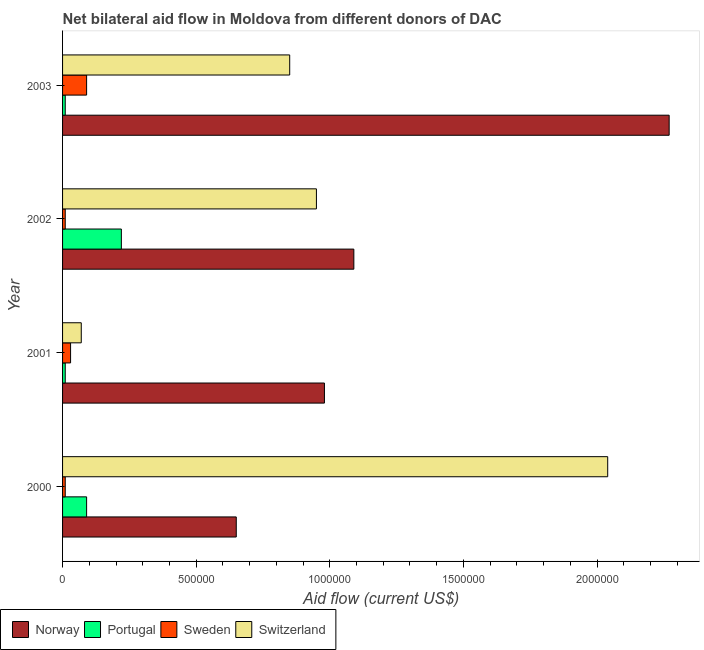How many different coloured bars are there?
Give a very brief answer. 4. How many groups of bars are there?
Offer a terse response. 4. Are the number of bars per tick equal to the number of legend labels?
Keep it short and to the point. Yes. Are the number of bars on each tick of the Y-axis equal?
Your answer should be very brief. Yes. How many bars are there on the 1st tick from the bottom?
Offer a very short reply. 4. What is the label of the 3rd group of bars from the top?
Give a very brief answer. 2001. In how many cases, is the number of bars for a given year not equal to the number of legend labels?
Your answer should be very brief. 0. What is the amount of aid given by switzerland in 2001?
Keep it short and to the point. 7.00e+04. Across all years, what is the maximum amount of aid given by switzerland?
Your response must be concise. 2.04e+06. Across all years, what is the minimum amount of aid given by switzerland?
Make the answer very short. 7.00e+04. In which year was the amount of aid given by norway minimum?
Provide a succinct answer. 2000. What is the total amount of aid given by norway in the graph?
Offer a terse response. 4.99e+06. What is the difference between the amount of aid given by norway in 2000 and the amount of aid given by portugal in 2002?
Your answer should be very brief. 4.30e+05. What is the average amount of aid given by sweden per year?
Provide a short and direct response. 3.50e+04. In the year 2000, what is the difference between the amount of aid given by switzerland and amount of aid given by sweden?
Provide a succinct answer. 2.03e+06. Is the amount of aid given by portugal in 2000 less than that in 2001?
Offer a very short reply. No. What is the difference between the highest and the second highest amount of aid given by norway?
Make the answer very short. 1.18e+06. What is the difference between the highest and the lowest amount of aid given by sweden?
Provide a succinct answer. 8.00e+04. In how many years, is the amount of aid given by portugal greater than the average amount of aid given by portugal taken over all years?
Make the answer very short. 2. Is the sum of the amount of aid given by sweden in 2000 and 2001 greater than the maximum amount of aid given by portugal across all years?
Ensure brevity in your answer.  No. What does the 1st bar from the top in 2002 represents?
Keep it short and to the point. Switzerland. Is it the case that in every year, the sum of the amount of aid given by norway and amount of aid given by portugal is greater than the amount of aid given by sweden?
Keep it short and to the point. Yes. How many bars are there?
Give a very brief answer. 16. Are all the bars in the graph horizontal?
Give a very brief answer. Yes. What is the difference between two consecutive major ticks on the X-axis?
Keep it short and to the point. 5.00e+05. Does the graph contain grids?
Give a very brief answer. No. How are the legend labels stacked?
Make the answer very short. Horizontal. What is the title of the graph?
Offer a terse response. Net bilateral aid flow in Moldova from different donors of DAC. What is the label or title of the X-axis?
Your answer should be very brief. Aid flow (current US$). What is the Aid flow (current US$) in Norway in 2000?
Your answer should be compact. 6.50e+05. What is the Aid flow (current US$) in Sweden in 2000?
Your response must be concise. 10000. What is the Aid flow (current US$) of Switzerland in 2000?
Your answer should be very brief. 2.04e+06. What is the Aid flow (current US$) in Norway in 2001?
Your answer should be compact. 9.80e+05. What is the Aid flow (current US$) of Portugal in 2001?
Make the answer very short. 10000. What is the Aid flow (current US$) of Norway in 2002?
Provide a succinct answer. 1.09e+06. What is the Aid flow (current US$) of Portugal in 2002?
Give a very brief answer. 2.20e+05. What is the Aid flow (current US$) in Switzerland in 2002?
Provide a short and direct response. 9.50e+05. What is the Aid flow (current US$) of Norway in 2003?
Provide a short and direct response. 2.27e+06. What is the Aid flow (current US$) of Switzerland in 2003?
Offer a terse response. 8.50e+05. Across all years, what is the maximum Aid flow (current US$) in Norway?
Ensure brevity in your answer.  2.27e+06. Across all years, what is the maximum Aid flow (current US$) in Portugal?
Provide a short and direct response. 2.20e+05. Across all years, what is the maximum Aid flow (current US$) in Sweden?
Provide a succinct answer. 9.00e+04. Across all years, what is the maximum Aid flow (current US$) in Switzerland?
Make the answer very short. 2.04e+06. Across all years, what is the minimum Aid flow (current US$) in Norway?
Provide a short and direct response. 6.50e+05. Across all years, what is the minimum Aid flow (current US$) of Sweden?
Provide a short and direct response. 10000. Across all years, what is the minimum Aid flow (current US$) of Switzerland?
Your response must be concise. 7.00e+04. What is the total Aid flow (current US$) in Norway in the graph?
Make the answer very short. 4.99e+06. What is the total Aid flow (current US$) in Portugal in the graph?
Give a very brief answer. 3.30e+05. What is the total Aid flow (current US$) of Sweden in the graph?
Provide a short and direct response. 1.40e+05. What is the total Aid flow (current US$) in Switzerland in the graph?
Provide a short and direct response. 3.91e+06. What is the difference between the Aid flow (current US$) in Norway in 2000 and that in 2001?
Your answer should be compact. -3.30e+05. What is the difference between the Aid flow (current US$) in Sweden in 2000 and that in 2001?
Provide a short and direct response. -2.00e+04. What is the difference between the Aid flow (current US$) in Switzerland in 2000 and that in 2001?
Provide a succinct answer. 1.97e+06. What is the difference between the Aid flow (current US$) in Norway in 2000 and that in 2002?
Your response must be concise. -4.40e+05. What is the difference between the Aid flow (current US$) of Portugal in 2000 and that in 2002?
Offer a terse response. -1.30e+05. What is the difference between the Aid flow (current US$) of Sweden in 2000 and that in 2002?
Provide a short and direct response. 0. What is the difference between the Aid flow (current US$) of Switzerland in 2000 and that in 2002?
Your answer should be compact. 1.09e+06. What is the difference between the Aid flow (current US$) of Norway in 2000 and that in 2003?
Keep it short and to the point. -1.62e+06. What is the difference between the Aid flow (current US$) of Portugal in 2000 and that in 2003?
Offer a terse response. 8.00e+04. What is the difference between the Aid flow (current US$) in Switzerland in 2000 and that in 2003?
Your answer should be very brief. 1.19e+06. What is the difference between the Aid flow (current US$) in Portugal in 2001 and that in 2002?
Provide a short and direct response. -2.10e+05. What is the difference between the Aid flow (current US$) in Sweden in 2001 and that in 2002?
Your answer should be very brief. 2.00e+04. What is the difference between the Aid flow (current US$) in Switzerland in 2001 and that in 2002?
Your response must be concise. -8.80e+05. What is the difference between the Aid flow (current US$) in Norway in 2001 and that in 2003?
Make the answer very short. -1.29e+06. What is the difference between the Aid flow (current US$) of Switzerland in 2001 and that in 2003?
Offer a very short reply. -7.80e+05. What is the difference between the Aid flow (current US$) in Norway in 2002 and that in 2003?
Keep it short and to the point. -1.18e+06. What is the difference between the Aid flow (current US$) of Switzerland in 2002 and that in 2003?
Your answer should be very brief. 1.00e+05. What is the difference between the Aid flow (current US$) of Norway in 2000 and the Aid flow (current US$) of Portugal in 2001?
Offer a very short reply. 6.40e+05. What is the difference between the Aid flow (current US$) in Norway in 2000 and the Aid flow (current US$) in Sweden in 2001?
Offer a very short reply. 6.20e+05. What is the difference between the Aid flow (current US$) in Norway in 2000 and the Aid flow (current US$) in Switzerland in 2001?
Your answer should be compact. 5.80e+05. What is the difference between the Aid flow (current US$) of Portugal in 2000 and the Aid flow (current US$) of Sweden in 2001?
Offer a very short reply. 6.00e+04. What is the difference between the Aid flow (current US$) in Norway in 2000 and the Aid flow (current US$) in Sweden in 2002?
Provide a short and direct response. 6.40e+05. What is the difference between the Aid flow (current US$) in Portugal in 2000 and the Aid flow (current US$) in Sweden in 2002?
Your answer should be very brief. 8.00e+04. What is the difference between the Aid flow (current US$) of Portugal in 2000 and the Aid flow (current US$) of Switzerland in 2002?
Keep it short and to the point. -8.60e+05. What is the difference between the Aid flow (current US$) of Sweden in 2000 and the Aid flow (current US$) of Switzerland in 2002?
Offer a terse response. -9.40e+05. What is the difference between the Aid flow (current US$) of Norway in 2000 and the Aid flow (current US$) of Portugal in 2003?
Your answer should be very brief. 6.40e+05. What is the difference between the Aid flow (current US$) of Norway in 2000 and the Aid flow (current US$) of Sweden in 2003?
Provide a short and direct response. 5.60e+05. What is the difference between the Aid flow (current US$) of Portugal in 2000 and the Aid flow (current US$) of Switzerland in 2003?
Ensure brevity in your answer.  -7.60e+05. What is the difference between the Aid flow (current US$) in Sweden in 2000 and the Aid flow (current US$) in Switzerland in 2003?
Your answer should be very brief. -8.40e+05. What is the difference between the Aid flow (current US$) in Norway in 2001 and the Aid flow (current US$) in Portugal in 2002?
Give a very brief answer. 7.60e+05. What is the difference between the Aid flow (current US$) of Norway in 2001 and the Aid flow (current US$) of Sweden in 2002?
Your response must be concise. 9.70e+05. What is the difference between the Aid flow (current US$) in Portugal in 2001 and the Aid flow (current US$) in Switzerland in 2002?
Provide a succinct answer. -9.40e+05. What is the difference between the Aid flow (current US$) in Sweden in 2001 and the Aid flow (current US$) in Switzerland in 2002?
Your answer should be very brief. -9.20e+05. What is the difference between the Aid flow (current US$) in Norway in 2001 and the Aid flow (current US$) in Portugal in 2003?
Give a very brief answer. 9.70e+05. What is the difference between the Aid flow (current US$) of Norway in 2001 and the Aid flow (current US$) of Sweden in 2003?
Give a very brief answer. 8.90e+05. What is the difference between the Aid flow (current US$) in Norway in 2001 and the Aid flow (current US$) in Switzerland in 2003?
Make the answer very short. 1.30e+05. What is the difference between the Aid flow (current US$) of Portugal in 2001 and the Aid flow (current US$) of Switzerland in 2003?
Your answer should be very brief. -8.40e+05. What is the difference between the Aid flow (current US$) in Sweden in 2001 and the Aid flow (current US$) in Switzerland in 2003?
Give a very brief answer. -8.20e+05. What is the difference between the Aid flow (current US$) of Norway in 2002 and the Aid flow (current US$) of Portugal in 2003?
Your answer should be compact. 1.08e+06. What is the difference between the Aid flow (current US$) in Norway in 2002 and the Aid flow (current US$) in Sweden in 2003?
Your answer should be compact. 1.00e+06. What is the difference between the Aid flow (current US$) of Portugal in 2002 and the Aid flow (current US$) of Switzerland in 2003?
Offer a very short reply. -6.30e+05. What is the difference between the Aid flow (current US$) in Sweden in 2002 and the Aid flow (current US$) in Switzerland in 2003?
Give a very brief answer. -8.40e+05. What is the average Aid flow (current US$) of Norway per year?
Give a very brief answer. 1.25e+06. What is the average Aid flow (current US$) of Portugal per year?
Offer a terse response. 8.25e+04. What is the average Aid flow (current US$) in Sweden per year?
Offer a terse response. 3.50e+04. What is the average Aid flow (current US$) of Switzerland per year?
Keep it short and to the point. 9.78e+05. In the year 2000, what is the difference between the Aid flow (current US$) of Norway and Aid flow (current US$) of Portugal?
Your answer should be compact. 5.60e+05. In the year 2000, what is the difference between the Aid flow (current US$) in Norway and Aid flow (current US$) in Sweden?
Your answer should be compact. 6.40e+05. In the year 2000, what is the difference between the Aid flow (current US$) in Norway and Aid flow (current US$) in Switzerland?
Your answer should be very brief. -1.39e+06. In the year 2000, what is the difference between the Aid flow (current US$) in Portugal and Aid flow (current US$) in Sweden?
Ensure brevity in your answer.  8.00e+04. In the year 2000, what is the difference between the Aid flow (current US$) of Portugal and Aid flow (current US$) of Switzerland?
Your answer should be compact. -1.95e+06. In the year 2000, what is the difference between the Aid flow (current US$) in Sweden and Aid flow (current US$) in Switzerland?
Provide a succinct answer. -2.03e+06. In the year 2001, what is the difference between the Aid flow (current US$) in Norway and Aid flow (current US$) in Portugal?
Ensure brevity in your answer.  9.70e+05. In the year 2001, what is the difference between the Aid flow (current US$) of Norway and Aid flow (current US$) of Sweden?
Offer a terse response. 9.50e+05. In the year 2001, what is the difference between the Aid flow (current US$) in Norway and Aid flow (current US$) in Switzerland?
Make the answer very short. 9.10e+05. In the year 2001, what is the difference between the Aid flow (current US$) in Portugal and Aid flow (current US$) in Switzerland?
Offer a very short reply. -6.00e+04. In the year 2002, what is the difference between the Aid flow (current US$) of Norway and Aid flow (current US$) of Portugal?
Ensure brevity in your answer.  8.70e+05. In the year 2002, what is the difference between the Aid flow (current US$) of Norway and Aid flow (current US$) of Sweden?
Provide a short and direct response. 1.08e+06. In the year 2002, what is the difference between the Aid flow (current US$) in Norway and Aid flow (current US$) in Switzerland?
Offer a very short reply. 1.40e+05. In the year 2002, what is the difference between the Aid flow (current US$) of Portugal and Aid flow (current US$) of Switzerland?
Ensure brevity in your answer.  -7.30e+05. In the year 2002, what is the difference between the Aid flow (current US$) in Sweden and Aid flow (current US$) in Switzerland?
Offer a terse response. -9.40e+05. In the year 2003, what is the difference between the Aid flow (current US$) of Norway and Aid flow (current US$) of Portugal?
Ensure brevity in your answer.  2.26e+06. In the year 2003, what is the difference between the Aid flow (current US$) of Norway and Aid flow (current US$) of Sweden?
Your answer should be very brief. 2.18e+06. In the year 2003, what is the difference between the Aid flow (current US$) in Norway and Aid flow (current US$) in Switzerland?
Provide a succinct answer. 1.42e+06. In the year 2003, what is the difference between the Aid flow (current US$) of Portugal and Aid flow (current US$) of Sweden?
Your answer should be compact. -8.00e+04. In the year 2003, what is the difference between the Aid flow (current US$) in Portugal and Aid flow (current US$) in Switzerland?
Provide a short and direct response. -8.40e+05. In the year 2003, what is the difference between the Aid flow (current US$) in Sweden and Aid flow (current US$) in Switzerland?
Your answer should be compact. -7.60e+05. What is the ratio of the Aid flow (current US$) in Norway in 2000 to that in 2001?
Provide a succinct answer. 0.66. What is the ratio of the Aid flow (current US$) in Sweden in 2000 to that in 2001?
Provide a short and direct response. 0.33. What is the ratio of the Aid flow (current US$) of Switzerland in 2000 to that in 2001?
Make the answer very short. 29.14. What is the ratio of the Aid flow (current US$) of Norway in 2000 to that in 2002?
Your answer should be very brief. 0.6. What is the ratio of the Aid flow (current US$) in Portugal in 2000 to that in 2002?
Your answer should be very brief. 0.41. What is the ratio of the Aid flow (current US$) in Switzerland in 2000 to that in 2002?
Keep it short and to the point. 2.15. What is the ratio of the Aid flow (current US$) of Norway in 2000 to that in 2003?
Your answer should be very brief. 0.29. What is the ratio of the Aid flow (current US$) in Switzerland in 2000 to that in 2003?
Ensure brevity in your answer.  2.4. What is the ratio of the Aid flow (current US$) of Norway in 2001 to that in 2002?
Provide a short and direct response. 0.9. What is the ratio of the Aid flow (current US$) of Portugal in 2001 to that in 2002?
Your answer should be very brief. 0.05. What is the ratio of the Aid flow (current US$) of Sweden in 2001 to that in 2002?
Offer a very short reply. 3. What is the ratio of the Aid flow (current US$) of Switzerland in 2001 to that in 2002?
Your answer should be very brief. 0.07. What is the ratio of the Aid flow (current US$) in Norway in 2001 to that in 2003?
Your answer should be compact. 0.43. What is the ratio of the Aid flow (current US$) in Switzerland in 2001 to that in 2003?
Keep it short and to the point. 0.08. What is the ratio of the Aid flow (current US$) in Norway in 2002 to that in 2003?
Provide a short and direct response. 0.48. What is the ratio of the Aid flow (current US$) in Portugal in 2002 to that in 2003?
Your response must be concise. 22. What is the ratio of the Aid flow (current US$) in Sweden in 2002 to that in 2003?
Offer a very short reply. 0.11. What is the ratio of the Aid flow (current US$) in Switzerland in 2002 to that in 2003?
Offer a terse response. 1.12. What is the difference between the highest and the second highest Aid flow (current US$) of Norway?
Give a very brief answer. 1.18e+06. What is the difference between the highest and the second highest Aid flow (current US$) of Portugal?
Provide a short and direct response. 1.30e+05. What is the difference between the highest and the second highest Aid flow (current US$) of Switzerland?
Your answer should be very brief. 1.09e+06. What is the difference between the highest and the lowest Aid flow (current US$) in Norway?
Offer a terse response. 1.62e+06. What is the difference between the highest and the lowest Aid flow (current US$) in Sweden?
Provide a succinct answer. 8.00e+04. What is the difference between the highest and the lowest Aid flow (current US$) in Switzerland?
Give a very brief answer. 1.97e+06. 